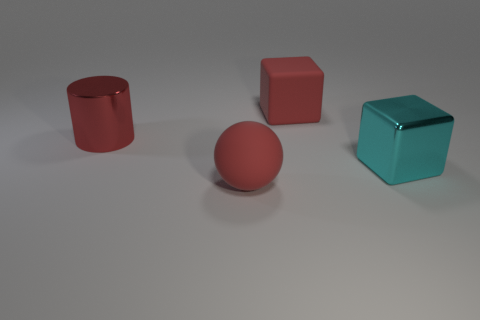What is the size of the block that is the same color as the cylinder?
Your answer should be very brief. Large. There is a big cylinder that is the same color as the large rubber cube; what is it made of?
Provide a short and direct response. Metal. The big ball has what color?
Ensure brevity in your answer.  Red. The large cube that is behind the metal object to the right of the big rubber sphere is what color?
Give a very brief answer. Red. Is there a large purple cylinder made of the same material as the red cube?
Your response must be concise. No. What is the material of the red thing that is in front of the big metal thing left of the cyan metallic block?
Give a very brief answer. Rubber. What number of red objects are the same shape as the cyan metallic thing?
Keep it short and to the point. 1. What is the shape of the big cyan metal object?
Your answer should be compact. Cube. Are there fewer green rubber balls than metal objects?
Offer a very short reply. Yes. Are there any other things that have the same size as the ball?
Your answer should be very brief. Yes. 